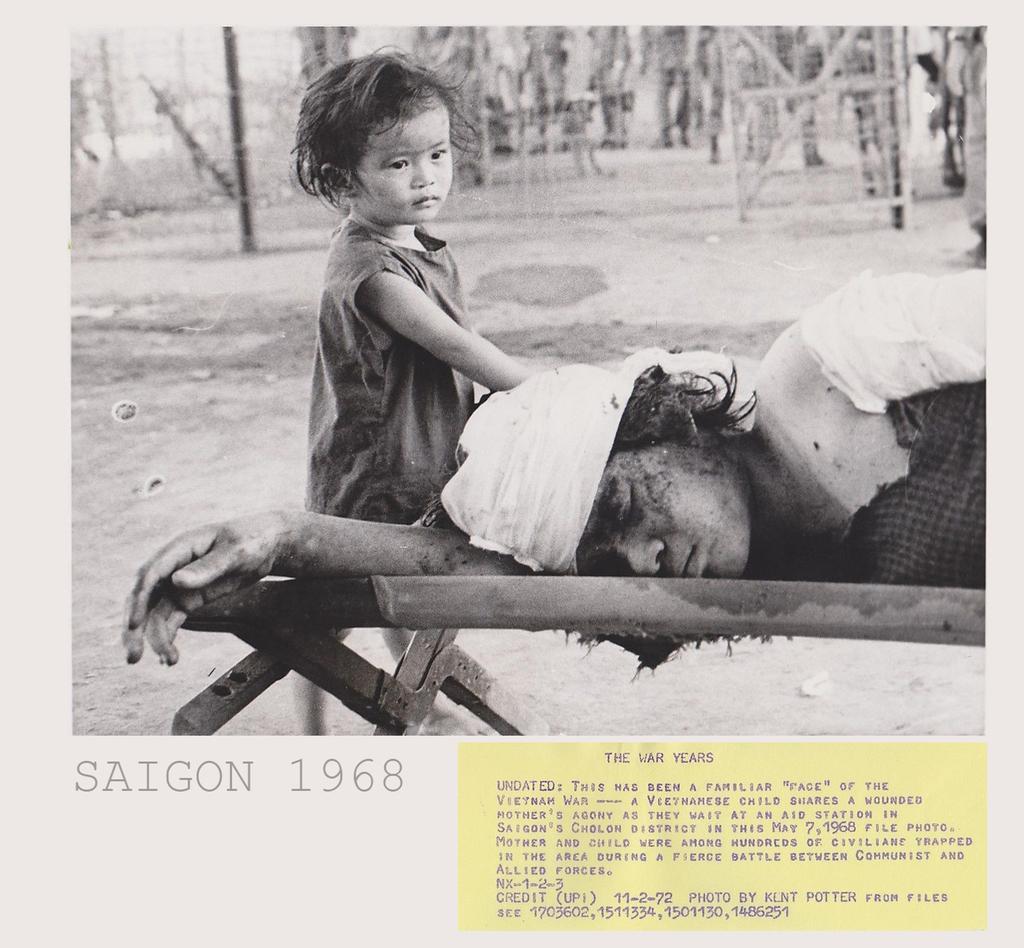Could you give a brief overview of what you see in this image? In this picture we can see the man sleeping on the small wooden bed. Behind there is a small girl standing. In the background we can see ground and some grill fencing. In the front bottom side there is some matter written on the photograph. 